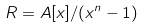Convert formula to latex. <formula><loc_0><loc_0><loc_500><loc_500>R = A [ x ] / ( x ^ { n } - 1 )</formula> 